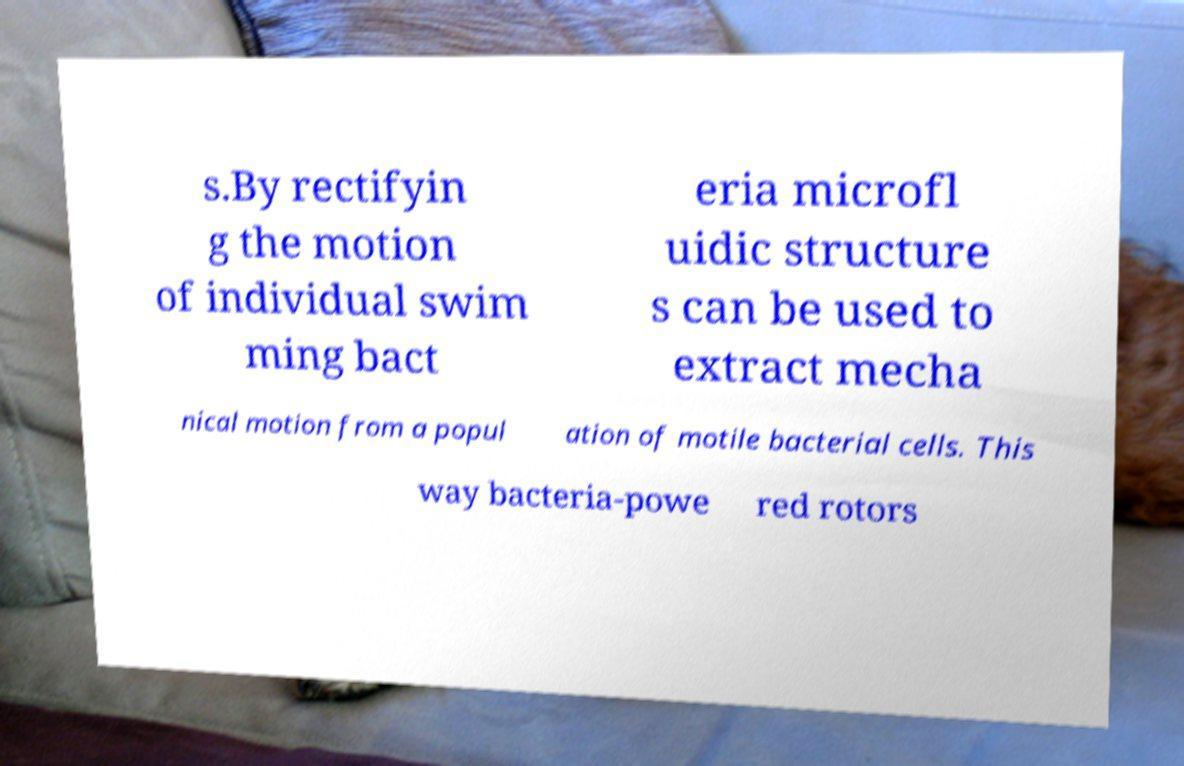For documentation purposes, I need the text within this image transcribed. Could you provide that? s.By rectifyin g the motion of individual swim ming bact eria microfl uidic structure s can be used to extract mecha nical motion from a popul ation of motile bacterial cells. This way bacteria-powe red rotors 